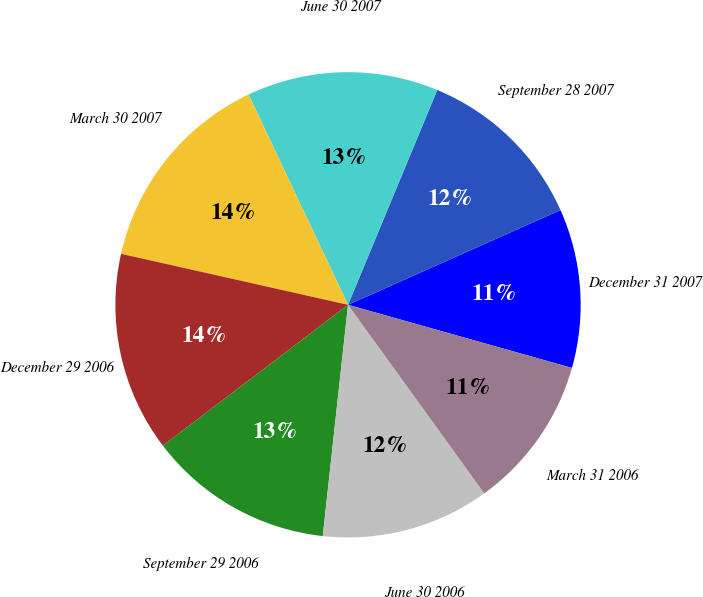Convert chart. <chart><loc_0><loc_0><loc_500><loc_500><pie_chart><fcel>December 31 2007<fcel>September 28 2007<fcel>June 30 2007<fcel>March 30 2007<fcel>December 29 2006<fcel>September 29 2006<fcel>June 30 2006<fcel>March 31 2006<nl><fcel>11.05%<fcel>12.06%<fcel>13.3%<fcel>14.45%<fcel>13.87%<fcel>12.92%<fcel>11.69%<fcel>10.67%<nl></chart> 